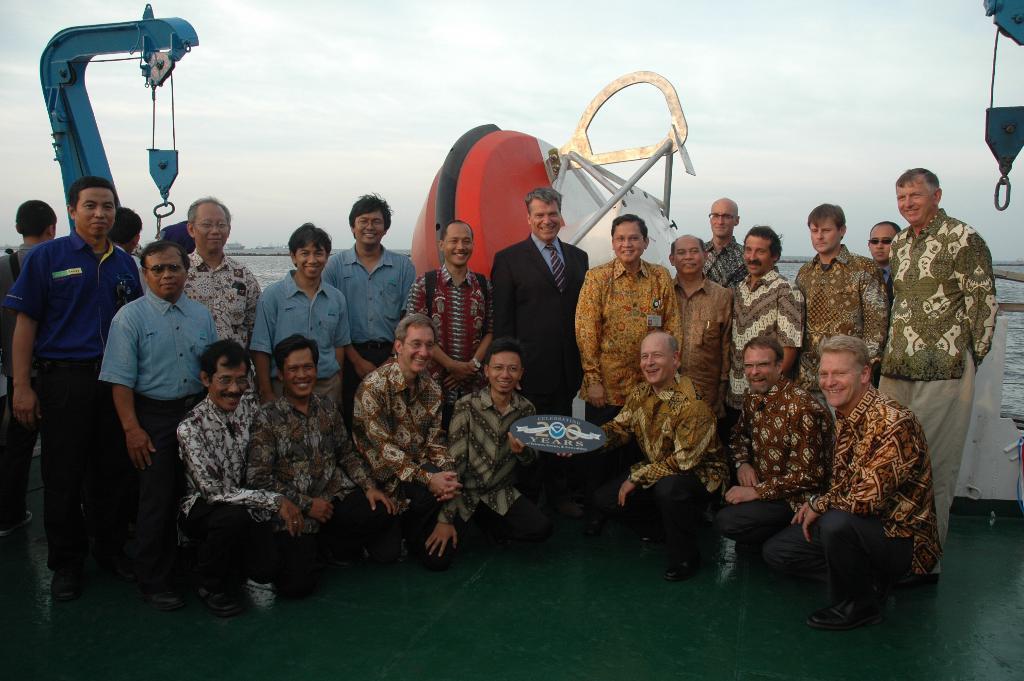Please provide a concise description of this image. In the center of the picture there are people. In the center the person is holding a memorandum, behind the people there are anchors and other objects. In the background there is a water body. Sky is cloudy. 